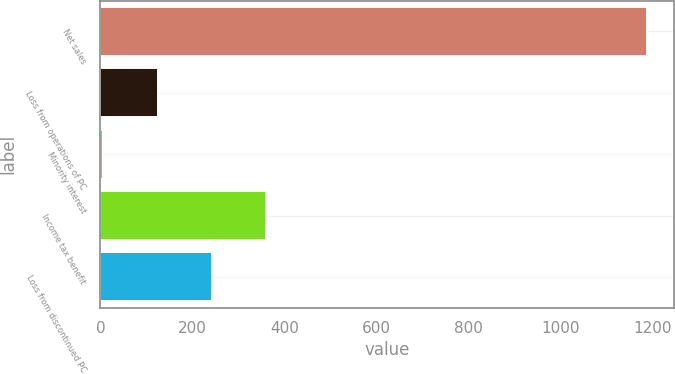<chart> <loc_0><loc_0><loc_500><loc_500><bar_chart><fcel>Net sales<fcel>Loss from operations of PC<fcel>Minority interest<fcel>Income tax benefit<fcel>Loss from discontinued PC<nl><fcel>1188.9<fcel>124.56<fcel>6.3<fcel>361.08<fcel>242.82<nl></chart> 